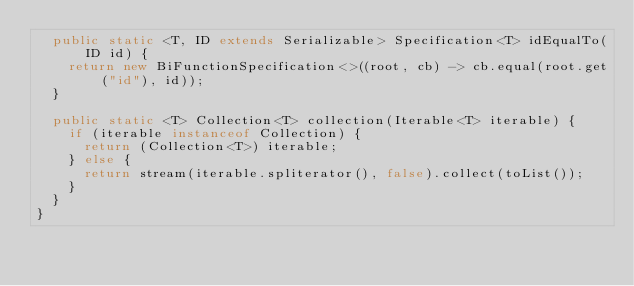Convert code to text. <code><loc_0><loc_0><loc_500><loc_500><_Java_>  public static <T, ID extends Serializable> Specification<T> idEqualTo(ID id) {
    return new BiFunctionSpecification<>((root, cb) -> cb.equal(root.get("id"), id));
  }

  public static <T> Collection<T> collection(Iterable<T> iterable) {
    if (iterable instanceof Collection) {
      return (Collection<T>) iterable;
    } else {
      return stream(iterable.spliterator(), false).collect(toList());
    }
  }
}
</code> 